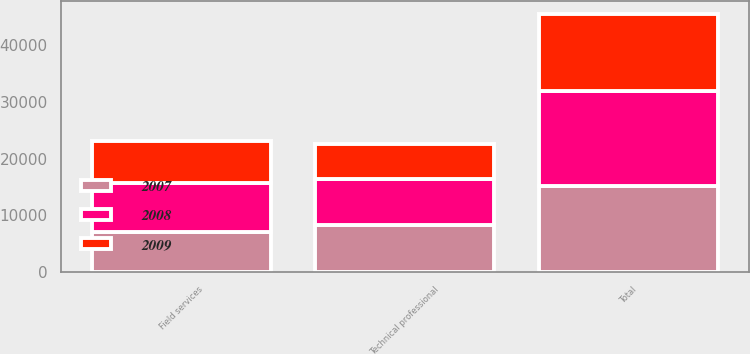<chart> <loc_0><loc_0><loc_500><loc_500><stacked_bar_chart><ecel><fcel>Technical professional<fcel>Field services<fcel>Total<nl><fcel>2007<fcel>8209.3<fcel>7010.1<fcel>15219.4<nl><fcel>2008<fcel>8085.2<fcel>8611.4<fcel>16696.6<nl><fcel>2009<fcel>6188.5<fcel>7397.3<fcel>13585.8<nl></chart> 